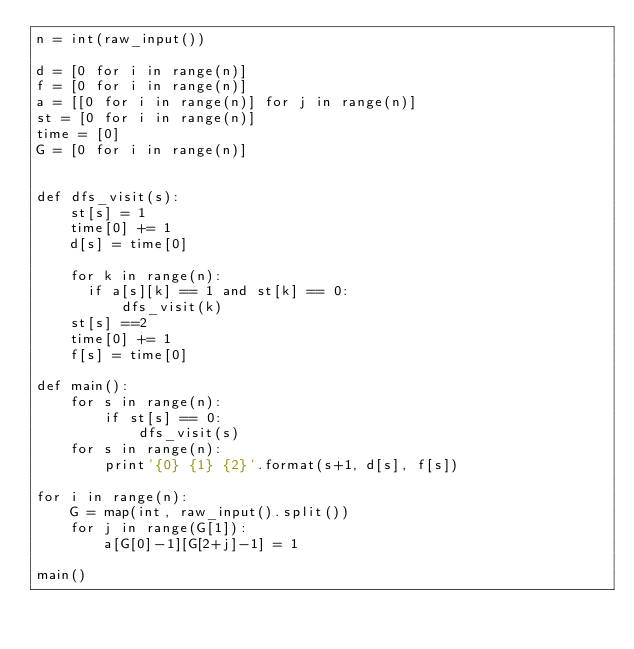<code> <loc_0><loc_0><loc_500><loc_500><_Python_>n = int(raw_input())

d = [0 for i in range(n)]
f = [0 for i in range(n)]
a = [[0 for i in range(n)] for j in range(n)]
st = [0 for i in range(n)]
time = [0]
G = [0 for i in range(n)]


def dfs_visit(s):
    st[s] = 1
    time[0] += 1
    d[s] = time[0]
    
    for k in range(n):  
      if a[s][k] == 1 and st[k] == 0:
          dfs_visit(k)
    st[s] ==2
    time[0] += 1
    f[s] = time[0]

def main():
    for s in range(n):
        if st[s] == 0:
            dfs_visit(s)
    for s in range(n):
        print'{0} {1} {2}'.format(s+1, d[s], f[s])

for i in range(n):
    G = map(int, raw_input().split())
    for j in range(G[1]):
        a[G[0]-1][G[2+j]-1] = 1

main()
   


       </code> 